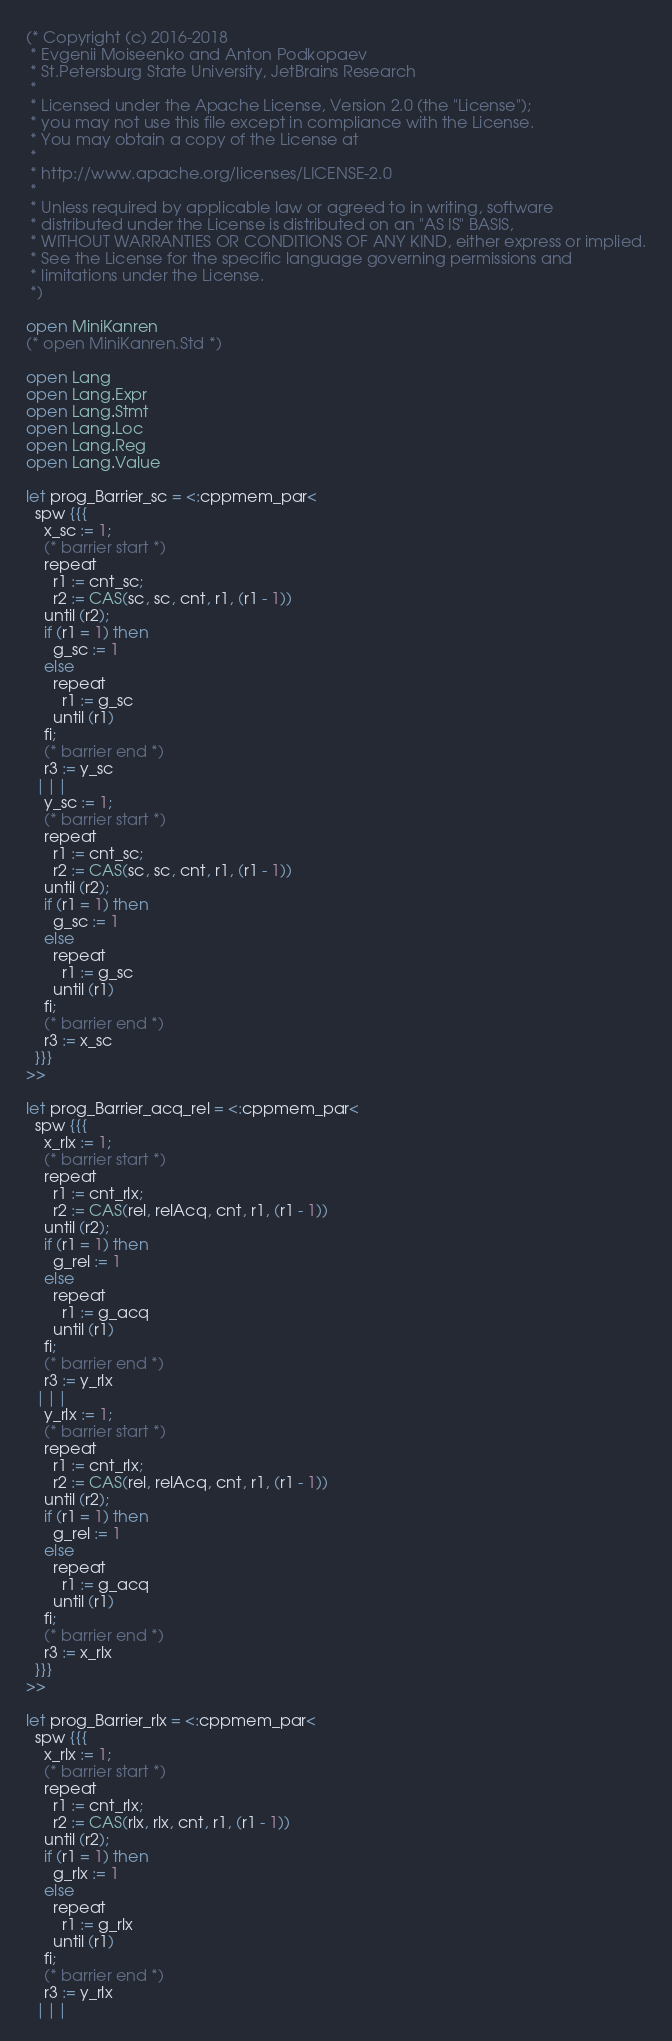<code> <loc_0><loc_0><loc_500><loc_500><_OCaml_>(* Copyright (c) 2016-2018
 * Evgenii Moiseenko and Anton Podkopaev
 * St.Petersburg State University, JetBrains Research
 *
 * Licensed under the Apache License, Version 2.0 (the "License");
 * you may not use this file except in compliance with the License.
 * You may obtain a copy of the License at
 *
 * http://www.apache.org/licenses/LICENSE-2.0
 *
 * Unless required by applicable law or agreed to in writing, software
 * distributed under the License is distributed on an "AS IS" BASIS,
 * WITHOUT WARRANTIES OR CONDITIONS OF ANY KIND, either express or implied.
 * See the License for the specific language governing permissions and
 * limitations under the License.
 *)

open MiniKanren
(* open MiniKanren.Std *)

open Lang
open Lang.Expr
open Lang.Stmt
open Lang.Loc
open Lang.Reg
open Lang.Value

let prog_Barrier_sc = <:cppmem_par<
  spw {{{
    x_sc := 1;
    (* barrier start *)
    repeat
      r1 := cnt_sc;
      r2 := CAS(sc, sc, cnt, r1, (r1 - 1))
    until (r2);
    if (r1 = 1) then
      g_sc := 1
    else
      repeat
        r1 := g_sc
      until (r1)
    fi;
    (* barrier end *)
    r3 := y_sc
  |||
    y_sc := 1;
    (* barrier start *)
    repeat
      r1 := cnt_sc;
      r2 := CAS(sc, sc, cnt, r1, (r1 - 1))
    until (r2);
    if (r1 = 1) then
      g_sc := 1
    else
      repeat
        r1 := g_sc
      until (r1)
    fi;
    (* barrier end *)
    r3 := x_sc
  }}}
>>

let prog_Barrier_acq_rel = <:cppmem_par<
  spw {{{
    x_rlx := 1;
    (* barrier start *)
    repeat
      r1 := cnt_rlx;
      r2 := CAS(rel, relAcq, cnt, r1, (r1 - 1))
    until (r2);
    if (r1 = 1) then
      g_rel := 1
    else
      repeat
        r1 := g_acq
      until (r1)
    fi;
    (* barrier end *)
    r3 := y_rlx
  |||
    y_rlx := 1;
    (* barrier start *)
    repeat
      r1 := cnt_rlx;
      r2 := CAS(rel, relAcq, cnt, r1, (r1 - 1))
    until (r2);
    if (r1 = 1) then
      g_rel := 1
    else
      repeat
        r1 := g_acq
      until (r1)
    fi;
    (* barrier end *)
    r3 := x_rlx
  }}}
>>

let prog_Barrier_rlx = <:cppmem_par<
  spw {{{
    x_rlx := 1;
    (* barrier start *)
    repeat
      r1 := cnt_rlx;
      r2 := CAS(rlx, rlx, cnt, r1, (r1 - 1))
    until (r2);
    if (r1 = 1) then
      g_rlx := 1
    else
      repeat
        r1 := g_rlx
      until (r1)
    fi;
    (* barrier end *)
    r3 := y_rlx
  |||</code> 